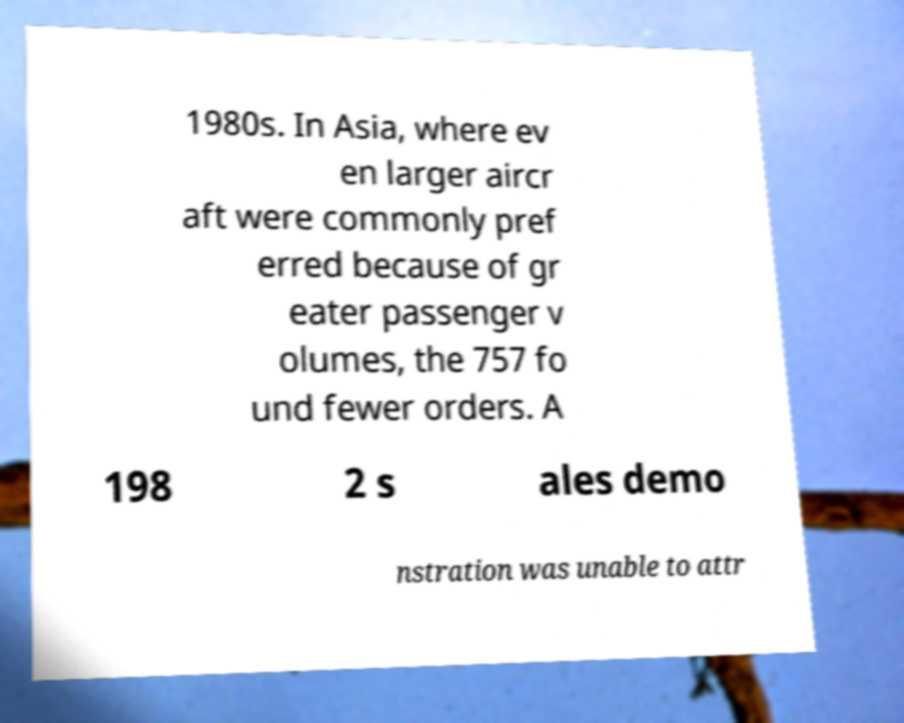Please read and relay the text visible in this image. What does it say? 1980s. In Asia, where ev en larger aircr aft were commonly pref erred because of gr eater passenger v olumes, the 757 fo und fewer orders. A 198 2 s ales demo nstration was unable to attr 